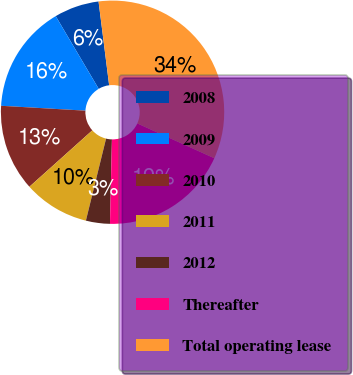Convert chart. <chart><loc_0><loc_0><loc_500><loc_500><pie_chart><fcel>2008<fcel>2009<fcel>2010<fcel>2011<fcel>2012<fcel>Thereafter<fcel>Total operating lease<nl><fcel>6.5%<fcel>15.58%<fcel>12.55%<fcel>9.53%<fcel>3.47%<fcel>18.61%<fcel>33.76%<nl></chart> 